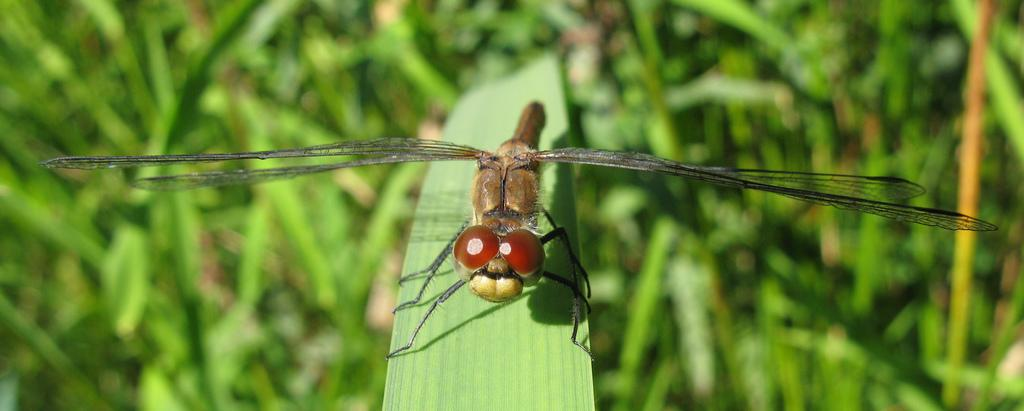What type of creature is present in the image? There is an insect in the image. What feature does the insect have for flying? The insect has wings. How does the insect move on the leaf? The insect has legs for moving on the leaf. What is the insect sitting on in the image? The insect is on a green color leaf. How would you describe the background of the image? The background of the image is blurred. What type of school can be seen in the background of the image? There is no school present in the image; it features an insect on a leaf with a blurred background. How many beads are attached to the insect's legs in the image? There are no beads present on the insect's legs in the image. 